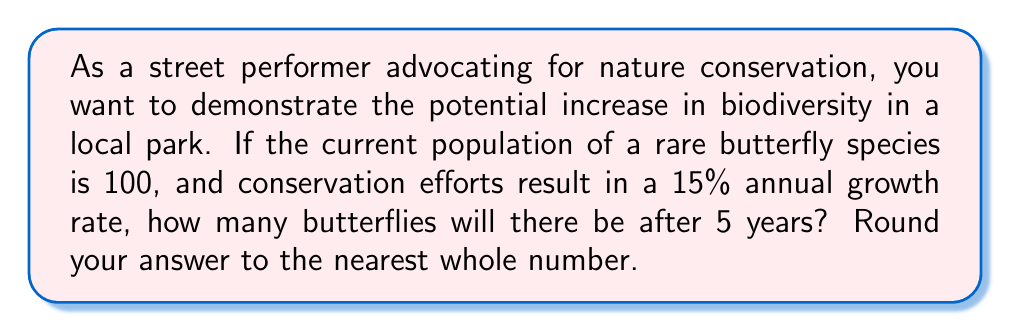Can you answer this question? To solve this problem, we'll use the exponential growth formula:

$$A = P(1 + r)^t$$

Where:
$A$ = Final amount
$P$ = Initial population
$r$ = Growth rate (as a decimal)
$t$ = Time period

Given:
$P = 100$ butterflies
$r = 15\% = 0.15$
$t = 5$ years

Let's substitute these values into the formula:

$$A = 100(1 + 0.15)^5$$

Now, let's calculate step-by-step:

1) First, calculate $(1 + 0.15)$:
   $1 + 0.15 = 1.15$

2) Now, raise 1.15 to the power of 5:
   $1.15^5 \approx 2.0113689$

3) Finally, multiply by the initial population:
   $100 \times 2.0113689 \approx 201.13689$

4) Rounding to the nearest whole number:
   $201.13689 \approx 201$

Therefore, after 5 years, there will be approximately 201 butterflies.
Answer: 201 butterflies 